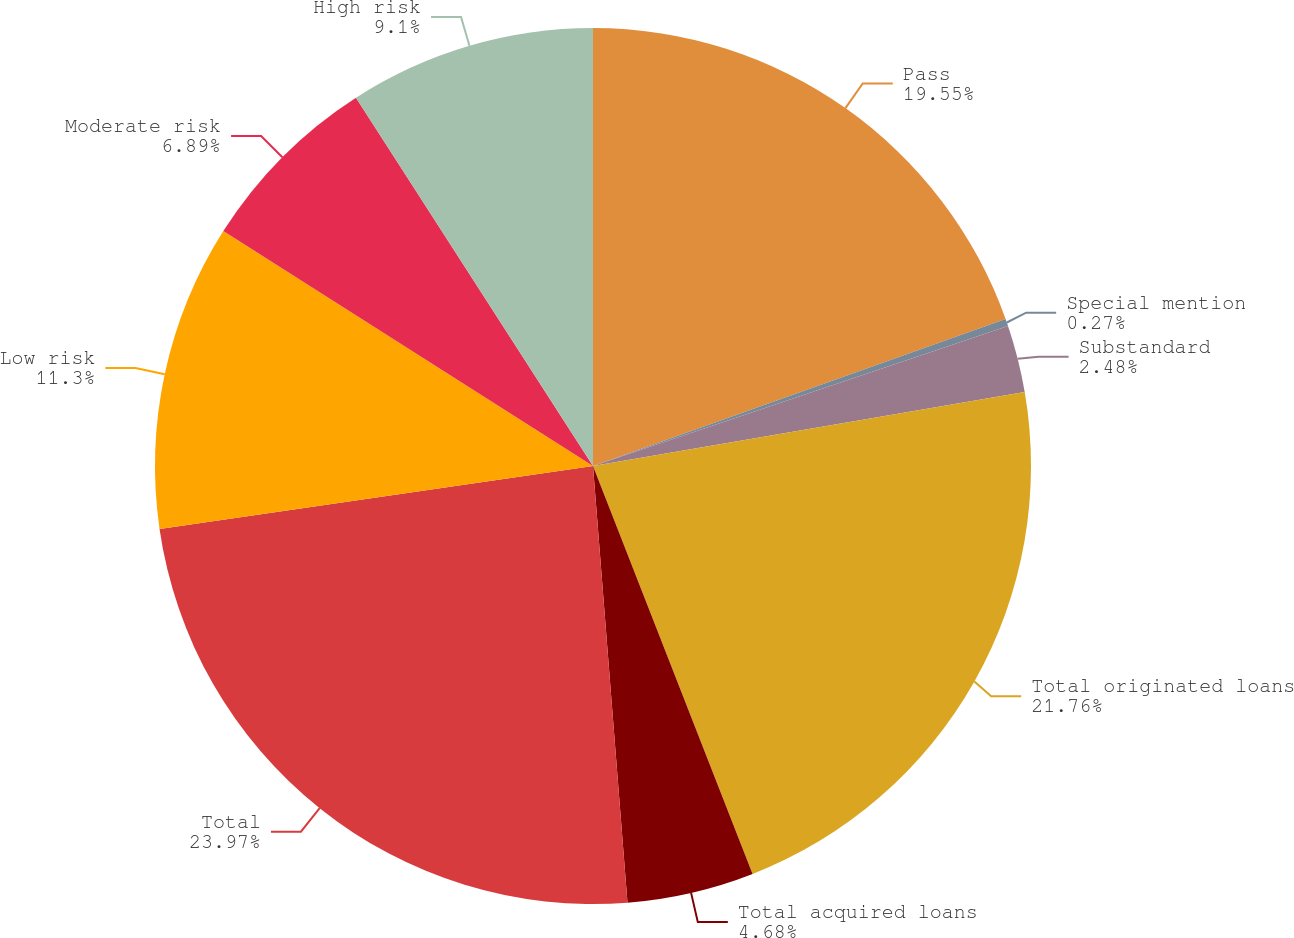Convert chart. <chart><loc_0><loc_0><loc_500><loc_500><pie_chart><fcel>Pass<fcel>Special mention<fcel>Substandard<fcel>Total originated loans<fcel>Total acquired loans<fcel>Total<fcel>Low risk<fcel>Moderate risk<fcel>High risk<nl><fcel>19.55%<fcel>0.27%<fcel>2.48%<fcel>21.76%<fcel>4.68%<fcel>23.96%<fcel>11.3%<fcel>6.89%<fcel>9.1%<nl></chart> 